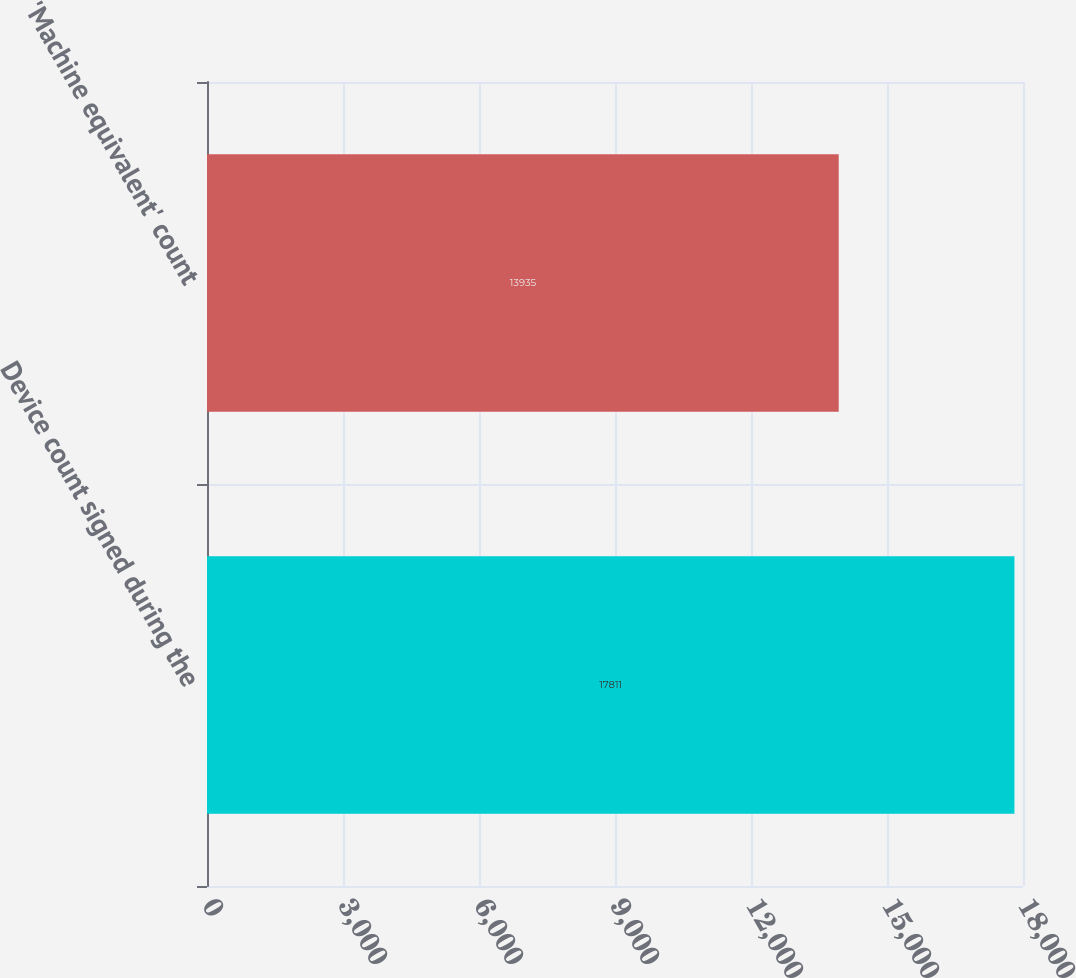Convert chart to OTSL. <chart><loc_0><loc_0><loc_500><loc_500><bar_chart><fcel>Device count signed during the<fcel>'Machine equivalent' count<nl><fcel>17811<fcel>13935<nl></chart> 